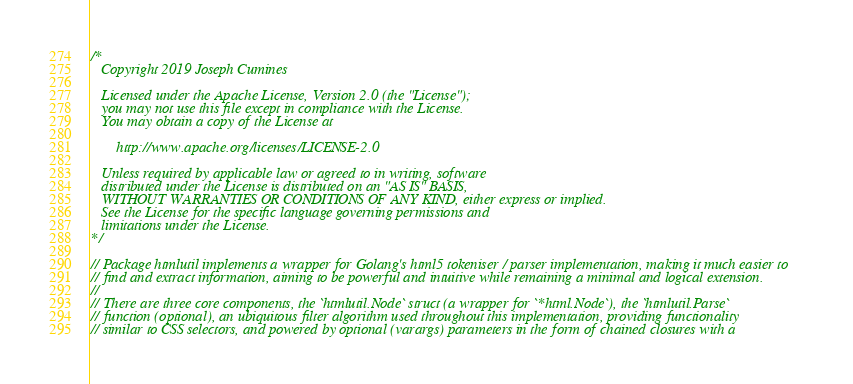Convert code to text. <code><loc_0><loc_0><loc_500><loc_500><_Go_>/*
   Copyright 2019 Joseph Cumines

   Licensed under the Apache License, Version 2.0 (the "License");
   you may not use this file except in compliance with the License.
   You may obtain a copy of the License at

       http://www.apache.org/licenses/LICENSE-2.0

   Unless required by applicable law or agreed to in writing, software
   distributed under the License is distributed on an "AS IS" BASIS,
   WITHOUT WARRANTIES OR CONDITIONS OF ANY KIND, either express or implied.
   See the License for the specific language governing permissions and
   limitations under the License.
*/

// Package htmlutil implements a wrapper for Golang's html5 tokeniser / parser implementation, making it much easier to
// find and extract information, aiming to be powerful and intuitive while remaining a minimal and logical extension.
//
// There are three core components, the `htmlutil.Node` struct (a wrapper for `*html.Node`), the `htmlutil.Parse`
// function (optional), an ubiquitous filter algorithm used throughout this implementation, providing functionality
// similar to CSS selectors, and powered by optional (varargs) parameters in the form of chained closures with a</code> 